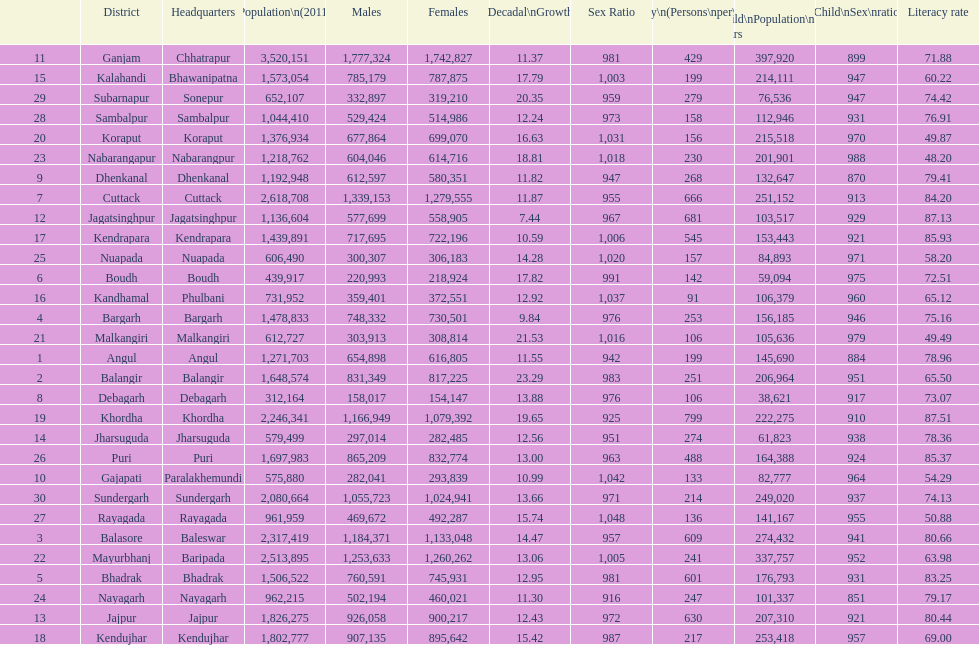Which district had the most people per km? Khordha. 